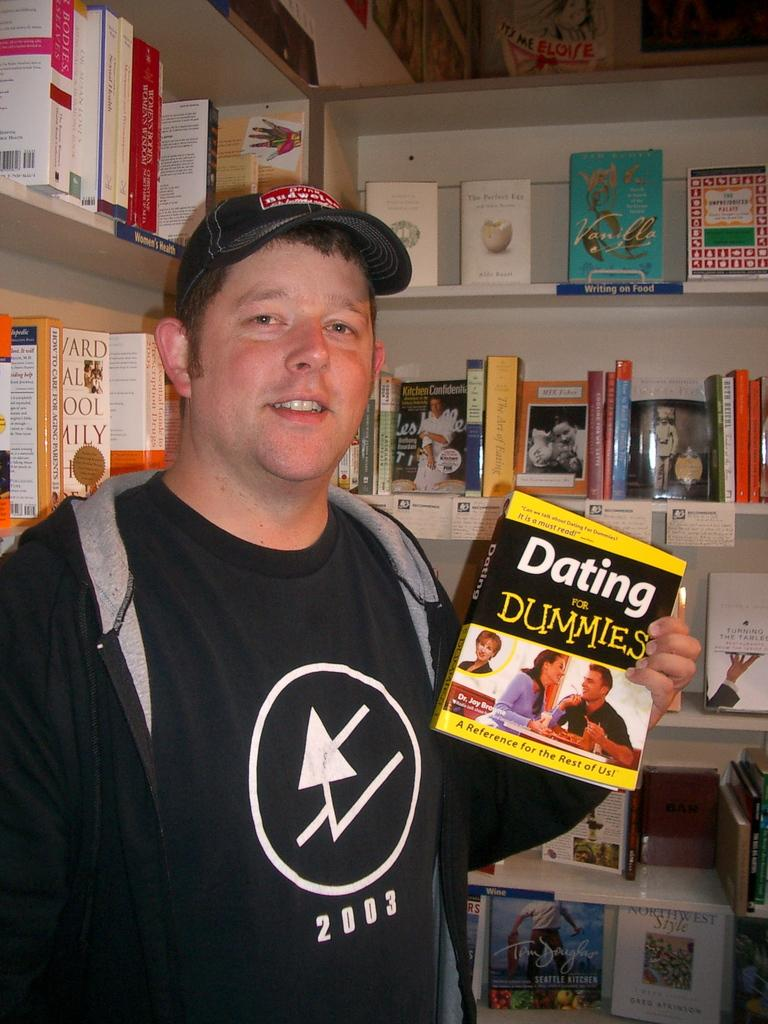<image>
Relay a brief, clear account of the picture shown. A guy holding a book that says Dating for Dummies. 